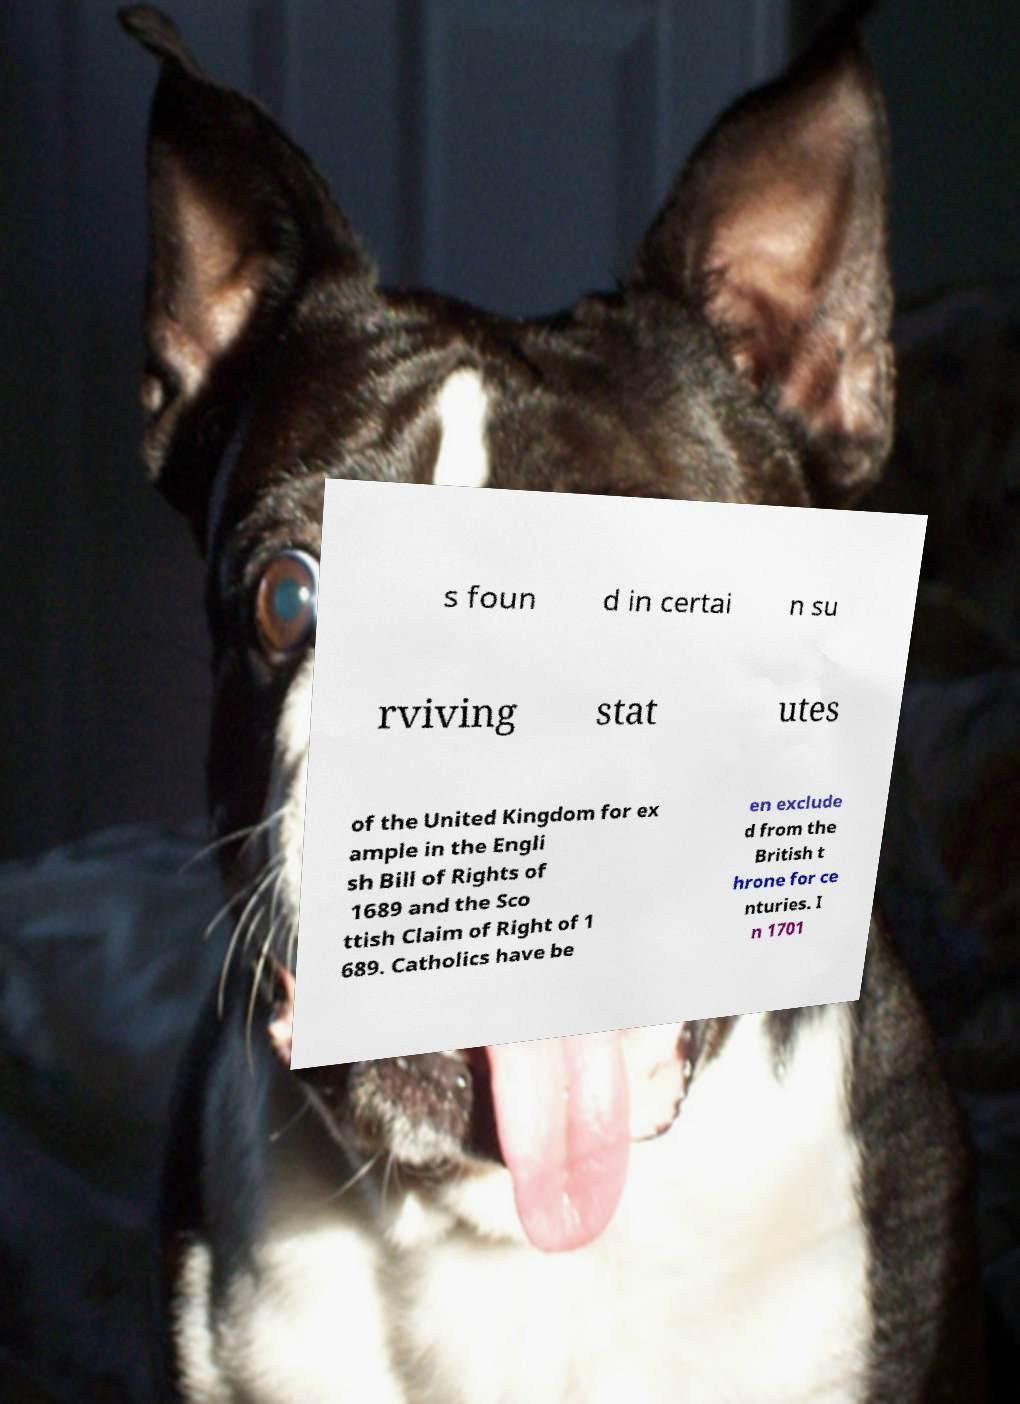There's text embedded in this image that I need extracted. Can you transcribe it verbatim? s foun d in certai n su rviving stat utes of the United Kingdom for ex ample in the Engli sh Bill of Rights of 1689 and the Sco ttish Claim of Right of 1 689. Catholics have be en exclude d from the British t hrone for ce nturies. I n 1701 